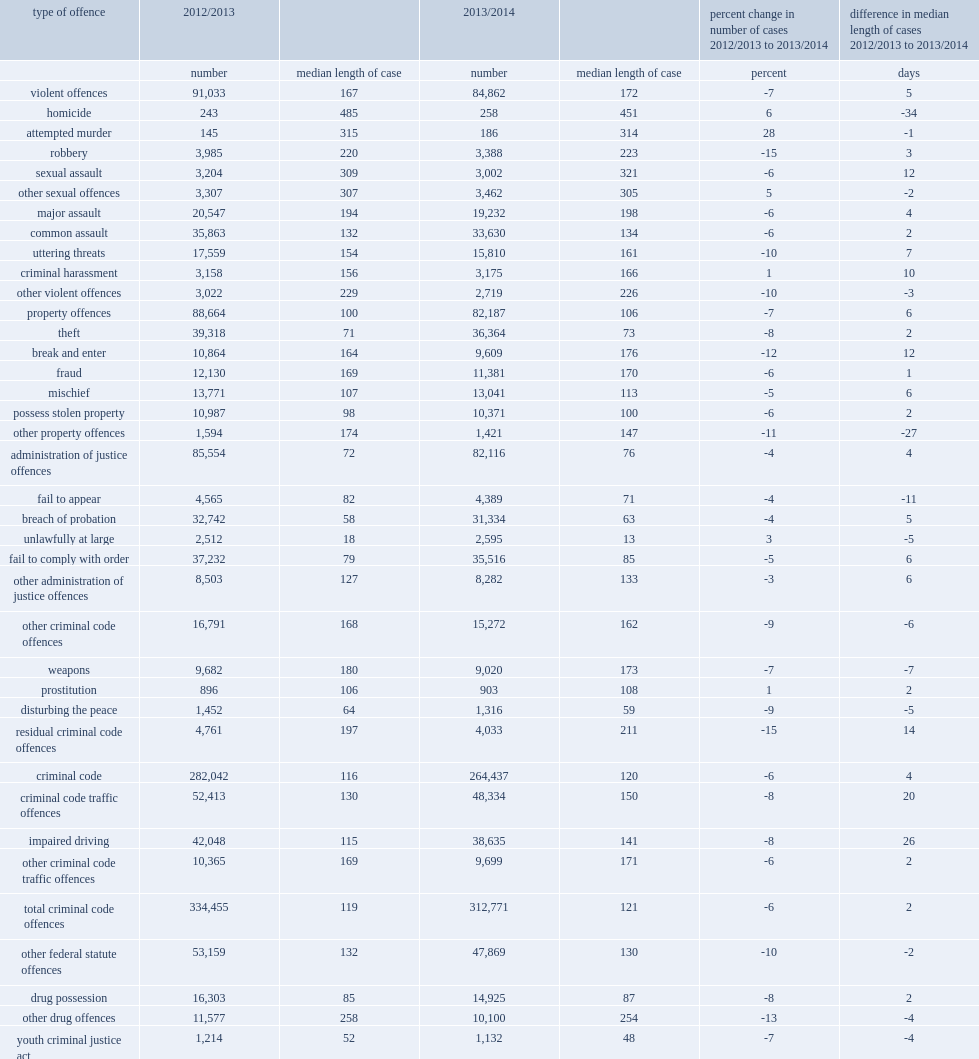What is the percentage of all cases completed in adult criminal court involved non-violent crime? 0.764691. What is the percentage of all cases completed in adult criminal court involved administration of justice offences? 0.227695. What is the percentage of all cases completed in adult criminal court involved criminal code traffic offences? 0.134023. What is the percentage of all cases completed in adult criminal court involved other non-violent criminal code offences? 0.042347. What is the percentage of all cases completed in adult criminal court involved other other federal statute offences? 0.132733. In 2013/2014, what is the percentage of completed cases involved violent offences? 0.235309. What is the percentage of all cases completed in adult criminal belongs to ten offence types in 2013/2014? 0.690897. What is the percentage of all cases completed in adult criminal were theft in 2013/2014? 0.100832. What is the percentage of all cases completed in adult criminal were failure to comply with a court order in 2013/2014? 0.09848. What is the percentage of all cases completed in adult criminal were common assault in 2013/2014? 0.093251. How many days did the longest type taketo complete and were the only offence type with a median length longer than one year? 451.0. In 2013/2014, how many days did sexual assault cases take? 321.0. How many days did attempted murder cases take? 314.0. 